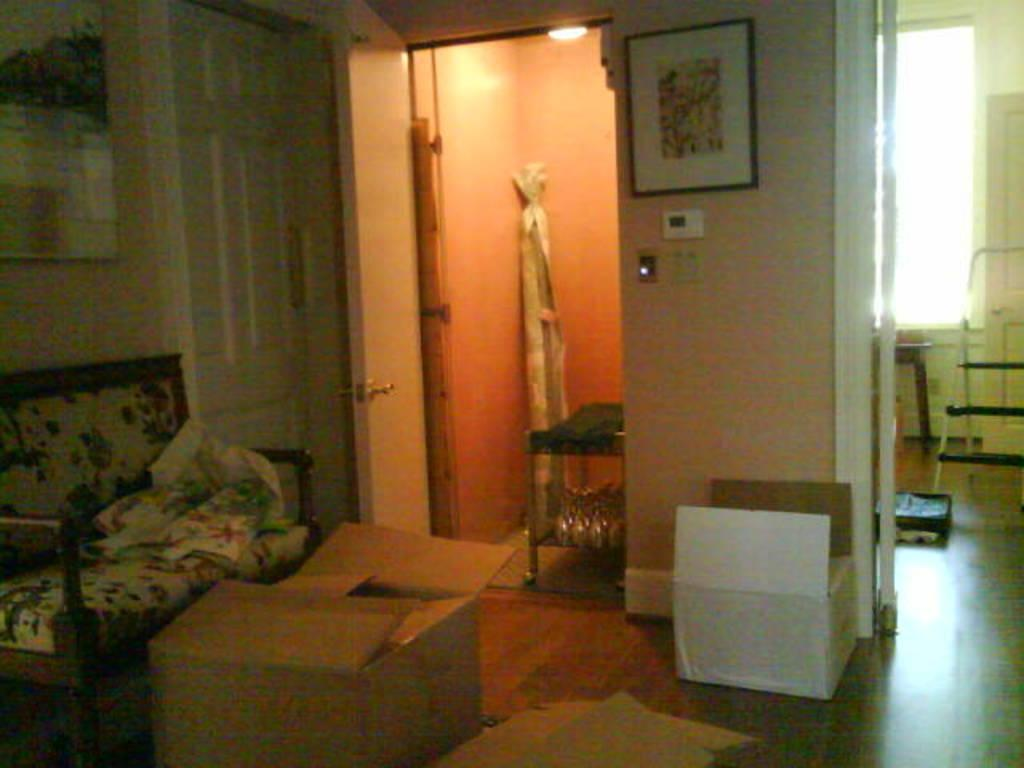What is on the chair in the image? There is cloth on a chair in the image. What is on the floor in the image? There are carton boxes on the floor in the image. What is on the walls in the image? There are frames on the walls in the image. What provides light in the image? There is a light source in the image. What can be used for entering or exiting in the image? There are doors in the image. What is on the table in the image? There are objects on a table in the image. What allows natural light to enter the room in the image? There is a window in the image. What other objects can be seen in the image? There are other objects in the image. What type of button is being used to hold up the underwear in the image? There is no button or underwear present in the image. How many fingers can be seen touching the objects on the table in the image? There are no fingers visible in the image; only objects on the table can be seen. 